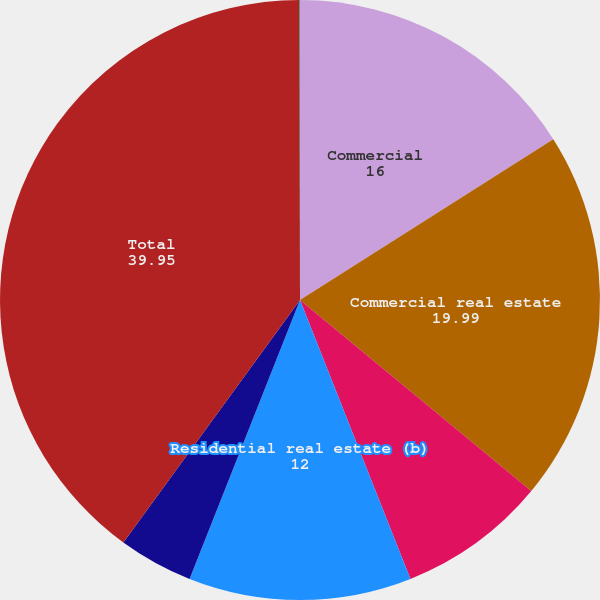Convert chart. <chart><loc_0><loc_0><loc_500><loc_500><pie_chart><fcel>Commercial<fcel>Commercial real estate<fcel>Home equity<fcel>Residential real estate (b)<fcel>Other consumer (c)<fcel>Total<fcel>Percentage of total loans<nl><fcel>16.0%<fcel>19.99%<fcel>8.01%<fcel>12.0%<fcel>4.02%<fcel>39.95%<fcel>0.03%<nl></chart> 